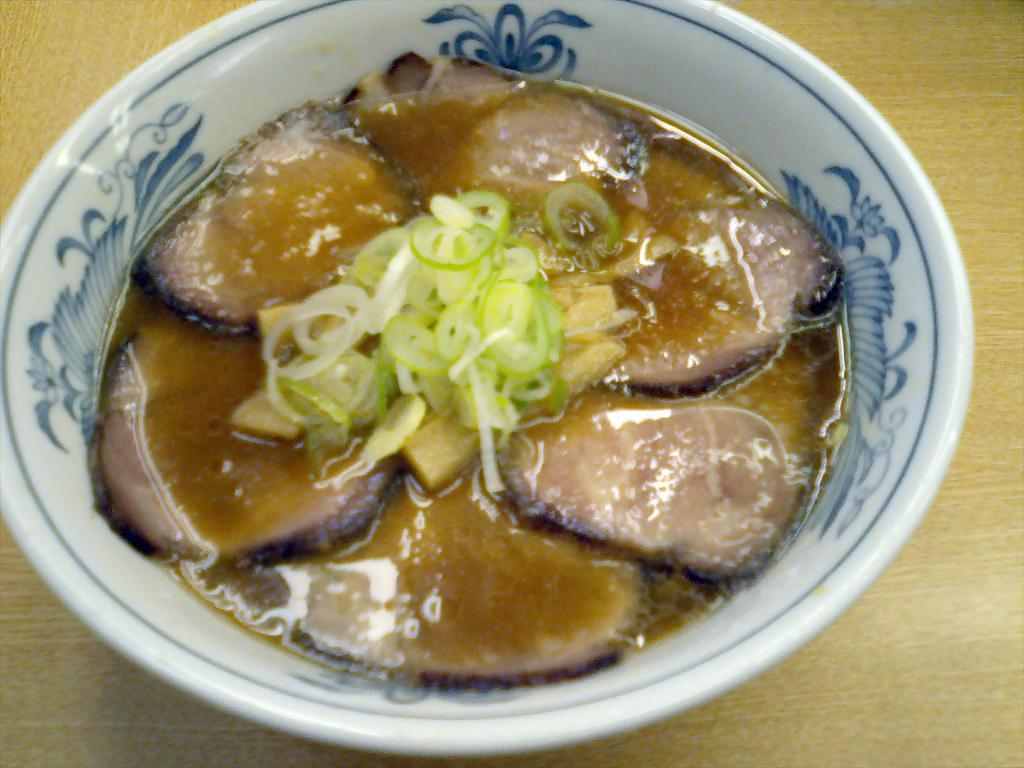What is in the bowl that is visible in the image? There are food items in a bowl in the image. How many clocks are visible in the image? There are no clocks present in the image; it only features a bowl of food items. 